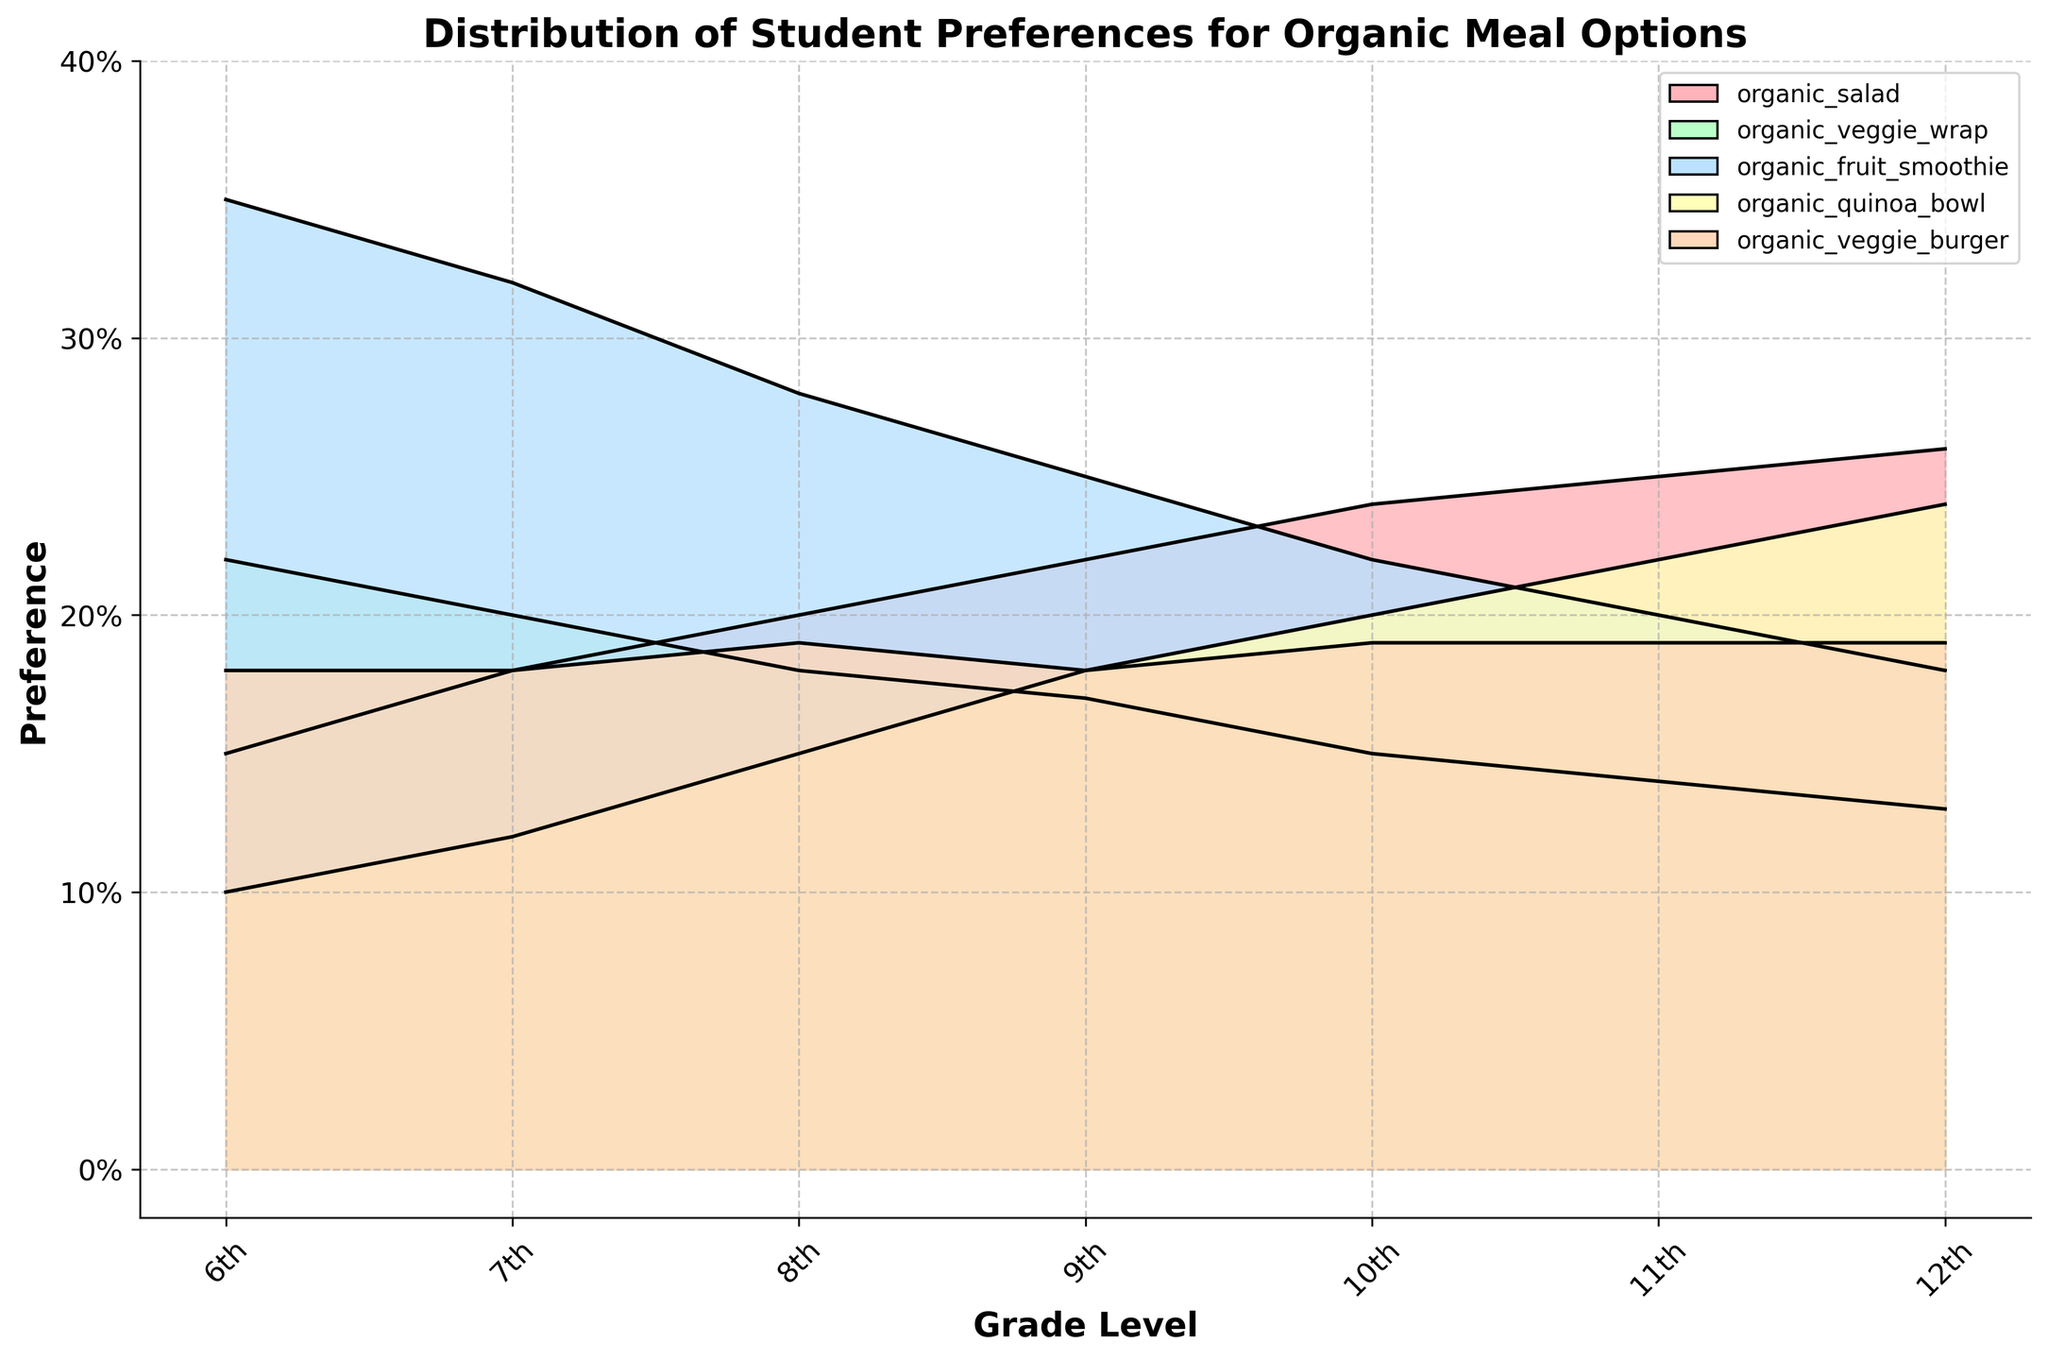Which grade level shows the highest preference for organic quinoa bowls? Look at the plot and find the tallest section for the organic quinoa bowls line, which is represented in its distinct color. Identify the corresponding grade level.
Answer: 12th What is the difference in preference for organic fruit smoothies between 6th and 12th grades? Identify the values representing preferences for organic fruit smoothies for both 6th and 12th grades from the plot. Subtract the 12th grade's preference percentage from the 6th grade's percentage to find the difference.
Answer: 0.35 - 0.18 = 0.17 Which organic meal option has the least variation in preference across all grade levels? Visually analyze the spread of each organic meal option line across all grade levels. Determine which line shows the least change in height from 6th to 12th grade.
Answer: Organic veggie burger Among the meal options, which one is consistently more preferred over the grade levels? Look at the plot and identify which organic meal option maintains a relatively higher value consistently across all grade levels.
Answer: Organic fruit smoothie What is the average preference for organic veggie wraps from grades 6 to 12? Retrieve the preference values for organic veggie wraps for all grades from the plot. Calculate their average: (0.22 + 0.20 + 0.18 + 0.17 + 0.15 + 0.14 + 0.13) / 7.
Answer: (0.22 + 0.20 + 0.18 + 0.17 + 0.15 + 0.14 + 0.13) / 7 = 0.17 Which grade level shows the largest increase in preference for organic quinoa bowls compared to the previous grade? Analyze the trajectories of the organic quinoa bowl lines and identify the grade level with the largest positive change compared to the preceding grade level. Compute changes for each grade and compare.
Answer: From 11th to 12th grade (0.24 - 0.22 = 0.02) Which meal option shows a decreasing trend in preference from 6th to 12th grade? Look at each meal option and follow the lines from 6th to 12th grade to determine which option consistently declines.
Answer: Organic veggie wrap How is the preference for organic salads trending across grade levels? Follow the organic salad line from grade 6 to grade 12 and observe whether it is increasing, decreasing, or staying the same.
Answer: Increasing Between grades 8 and 9, which meal option has the smallest change in preference? For each meal option, look at the changes in height between grades 8 and 9. Identify the meal option with the smallest change. Visualize the minimal difference between two points.
Answer: Organic veggie burger How do preferences for organic veggie wraps compare between grades 7 and 11? Examine the values representing organic veggie wraps preferences for grades 7 and 11 on the plot and compare them directly.
Answer: 7th (0.20) vs 11th (0.14); 7th grade is higher 